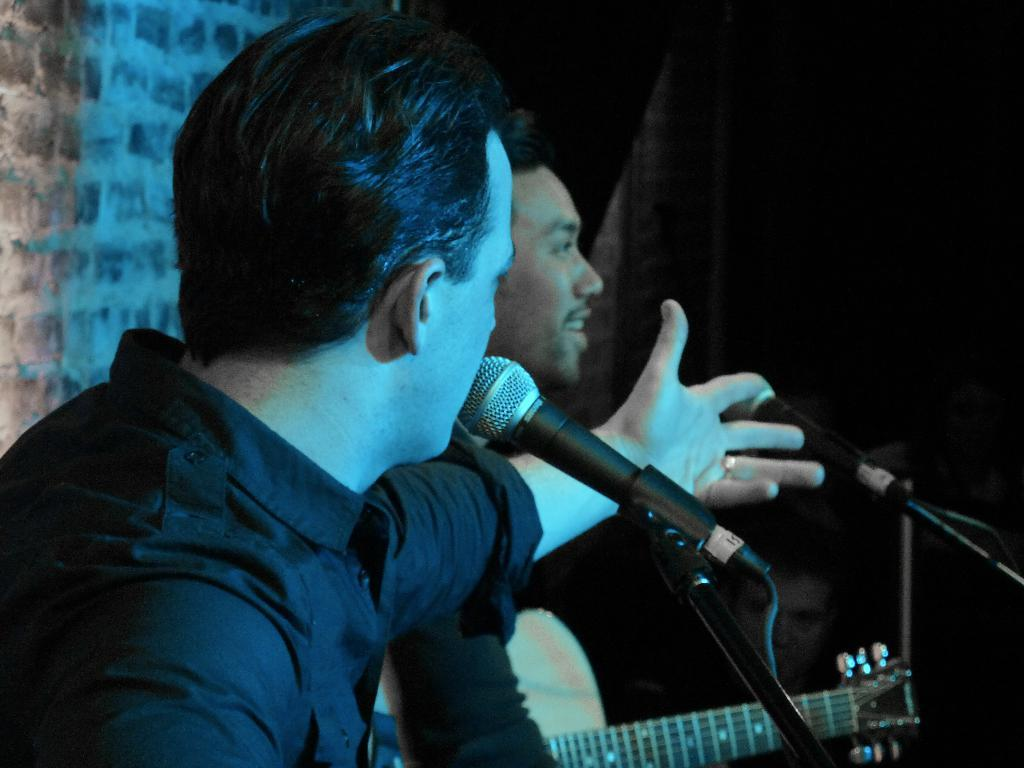How many people are in the image? There are two people in the image. What is the person on the left wearing? The person on the left is wearing a black shirt. What is the person in the black shirt doing with their left hand? The person in the black shirt has raised their left hand. What object is the person in the black shirt standing in front of? The person in the black shirt is standing in front of a microphone. What type of winter clothing is the manager wearing in the image? There is no manager present in the image, and no winter clothing is visible. 